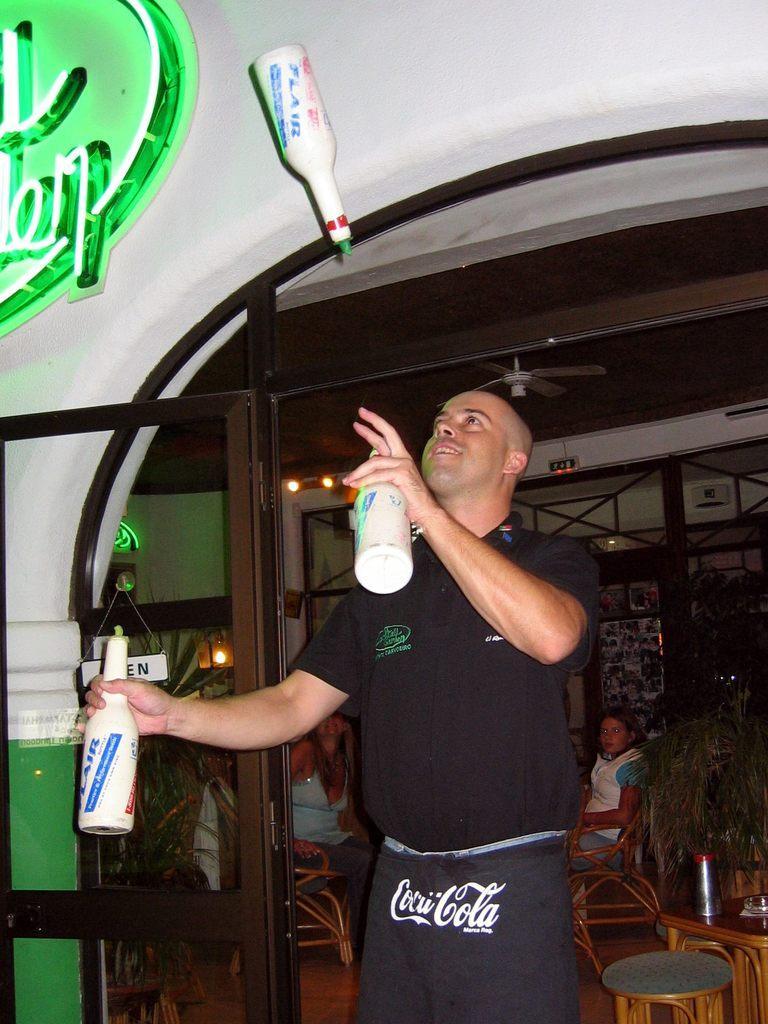In one or two sentences, can you explain what this image depicts? In this image I can see a man wearing black t-shirt, standing and flipping the bottles. On the right side of the image there is a table and chairs around it. In the background there are some people sitting on the chairs and looking at the person who is flipping the bottles. on the top of the image there is a wall. 